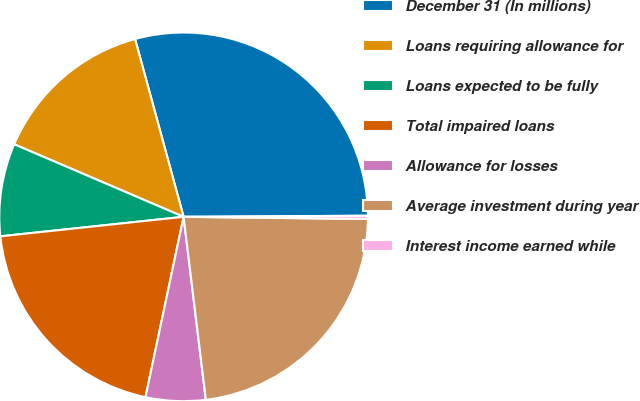Convert chart to OTSL. <chart><loc_0><loc_0><loc_500><loc_500><pie_chart><fcel>December 31 (In millions)<fcel>Loans requiring allowance for<fcel>Loans expected to be fully<fcel>Total impaired loans<fcel>Allowance for losses<fcel>Average investment during year<fcel>Interest income earned while<nl><fcel>29.15%<fcel>14.32%<fcel>8.13%<fcel>20.0%<fcel>5.24%<fcel>22.89%<fcel>0.28%<nl></chart> 